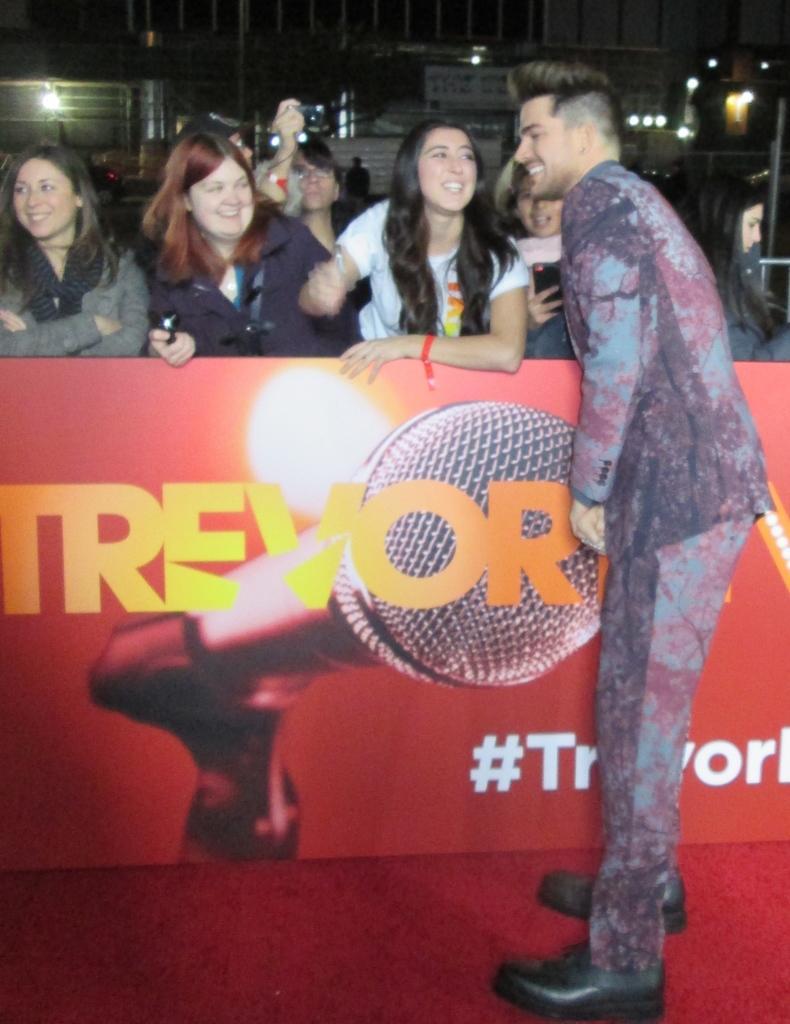Describe this image in one or two sentences. In this image there is a person standing. Beside the person there are few women standing with a smile on their face. In the background of the image there are buildings. Beside the person there is a hoarding. 